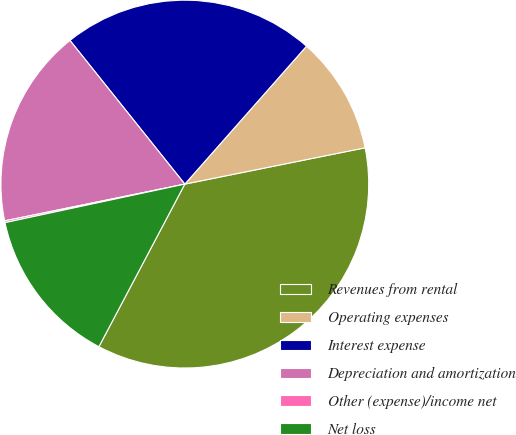<chart> <loc_0><loc_0><loc_500><loc_500><pie_chart><fcel>Revenues from rental<fcel>Operating expenses<fcel>Interest expense<fcel>Depreciation and amortization<fcel>Other (expense)/income net<fcel>Net loss<nl><fcel>35.9%<fcel>10.33%<fcel>22.24%<fcel>17.47%<fcel>0.16%<fcel>13.9%<nl></chart> 